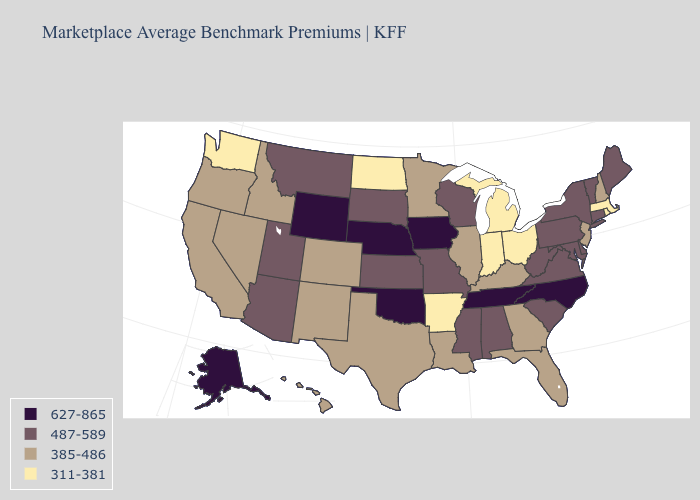Does Oklahoma have a higher value than Arkansas?
Answer briefly. Yes. What is the value of Tennessee?
Keep it brief. 627-865. Name the states that have a value in the range 311-381?
Answer briefly. Arkansas, Indiana, Massachusetts, Michigan, North Dakota, Ohio, Rhode Island, Washington. Does the map have missing data?
Keep it brief. No. Does Arkansas have the lowest value in the South?
Write a very short answer. Yes. Among the states that border Oregon , does Idaho have the lowest value?
Give a very brief answer. No. Among the states that border Minnesota , which have the lowest value?
Be succinct. North Dakota. What is the value of Oregon?
Concise answer only. 385-486. What is the lowest value in the USA?
Answer briefly. 311-381. What is the value of Montana?
Give a very brief answer. 487-589. Which states have the highest value in the USA?
Short answer required. Alaska, Iowa, Nebraska, North Carolina, Oklahoma, Tennessee, Wyoming. What is the lowest value in states that border Oregon?
Answer briefly. 311-381. What is the highest value in states that border New Hampshire?
Quick response, please. 487-589. Among the states that border Ohio , does Pennsylvania have the lowest value?
Keep it brief. No. Name the states that have a value in the range 385-486?
Answer briefly. California, Colorado, Florida, Georgia, Hawaii, Idaho, Illinois, Kentucky, Louisiana, Minnesota, Nevada, New Hampshire, New Jersey, New Mexico, Oregon, Texas. 